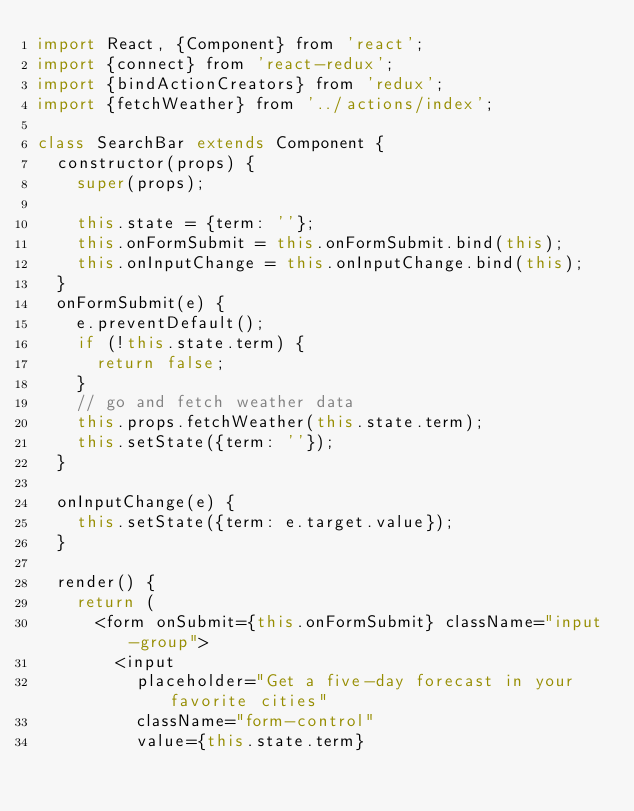Convert code to text. <code><loc_0><loc_0><loc_500><loc_500><_JavaScript_>import React, {Component} from 'react';
import {connect} from 'react-redux';
import {bindActionCreators} from 'redux';
import {fetchWeather} from '../actions/index';

class SearchBar extends Component {
  constructor(props) {
    super(props);

    this.state = {term: ''};
    this.onFormSubmit = this.onFormSubmit.bind(this);
    this.onInputChange = this.onInputChange.bind(this);
  }
  onFormSubmit(e) {
    e.preventDefault();
    if (!this.state.term) {
      return false;
    }
    // go and fetch weather data
    this.props.fetchWeather(this.state.term);
    this.setState({term: ''});
  }

  onInputChange(e) {
    this.setState({term: e.target.value});
  }

  render() {
    return (
      <form onSubmit={this.onFormSubmit} className="input-group">
        <input
          placeholder="Get a five-day forecast in your favorite cities"
          className="form-control"
          value={this.state.term}</code> 